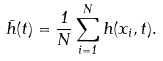<formula> <loc_0><loc_0><loc_500><loc_500>\bar { h } ( t ) = \frac { 1 } { N } \sum _ { i = 1 } ^ { N } h ( x _ { i } , t ) .</formula> 